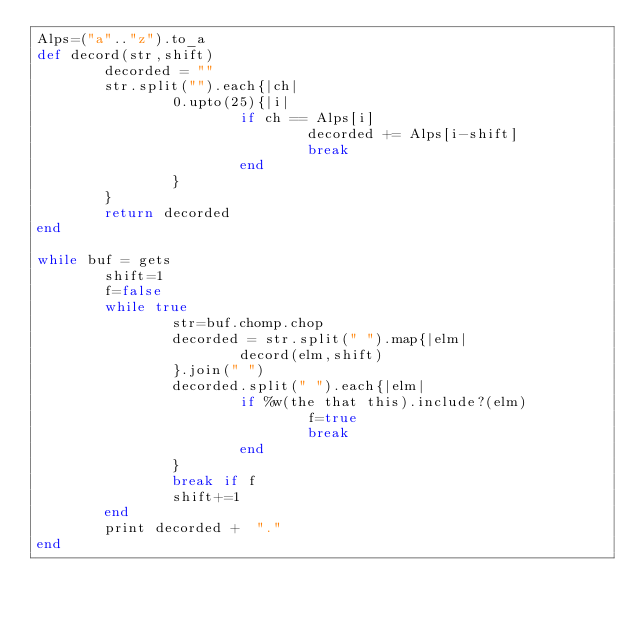Convert code to text. <code><loc_0><loc_0><loc_500><loc_500><_Ruby_>Alps=("a".."z").to_a
def decord(str,shift)           
        decorded = ""
        str.split("").each{|ch|
                0.upto(25){|i|
                        if ch == Alps[i]
                                decorded += Alps[i-shift]  
                                break
                        end
                }
        }
        return decorded
end

while buf = gets
        shift=1
        f=false
        while true
                str=buf.chomp.chop            
                decorded = str.split(" ").map{|elm|
                        decord(elm,shift)                       
                }.join(" ")
                decorded.split(" ").each{|elm|          
                        if %w(the that this).include?(elm)
                                f=true
                                break
                        end
                }
                break if f
                shift+=1
        end
        print decorded +  "."
end</code> 